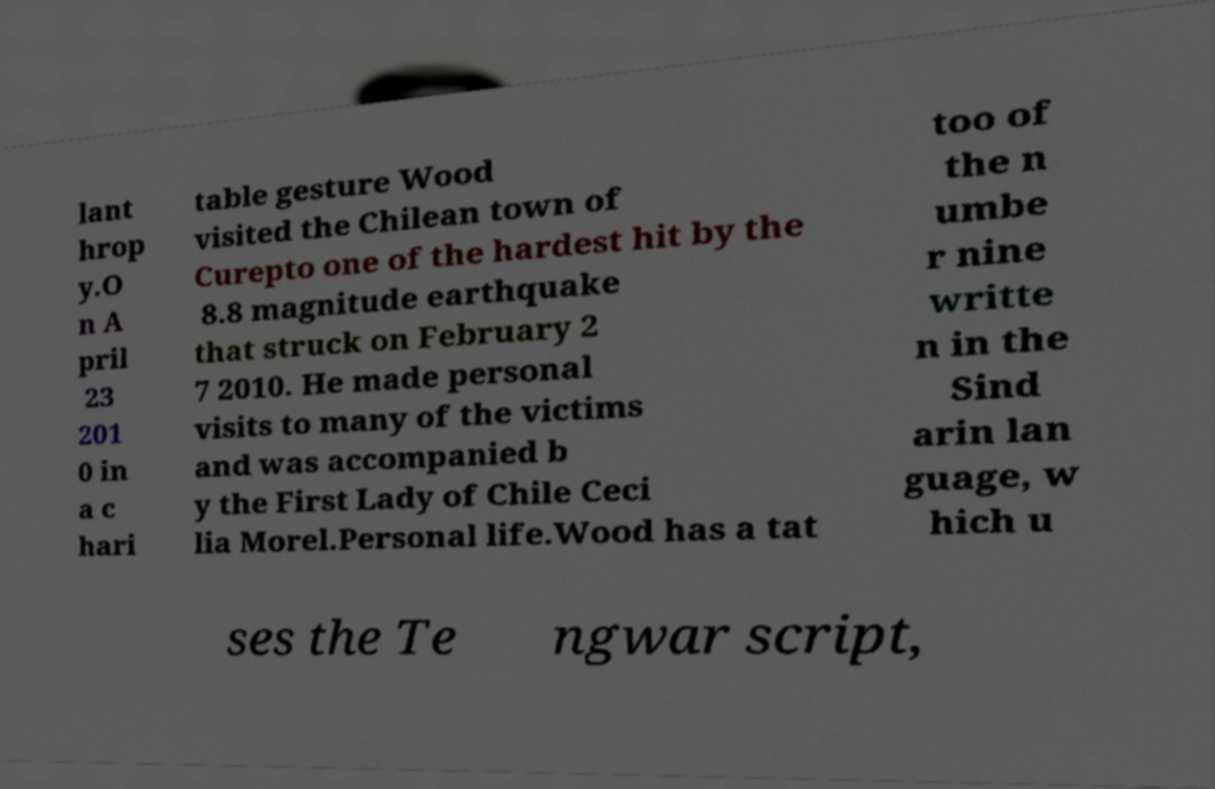Could you extract and type out the text from this image? lant hrop y.O n A pril 23 201 0 in a c hari table gesture Wood visited the Chilean town of Curepto one of the hardest hit by the 8.8 magnitude earthquake that struck on February 2 7 2010. He made personal visits to many of the victims and was accompanied b y the First Lady of Chile Ceci lia Morel.Personal life.Wood has a tat too of the n umbe r nine writte n in the Sind arin lan guage, w hich u ses the Te ngwar script, 